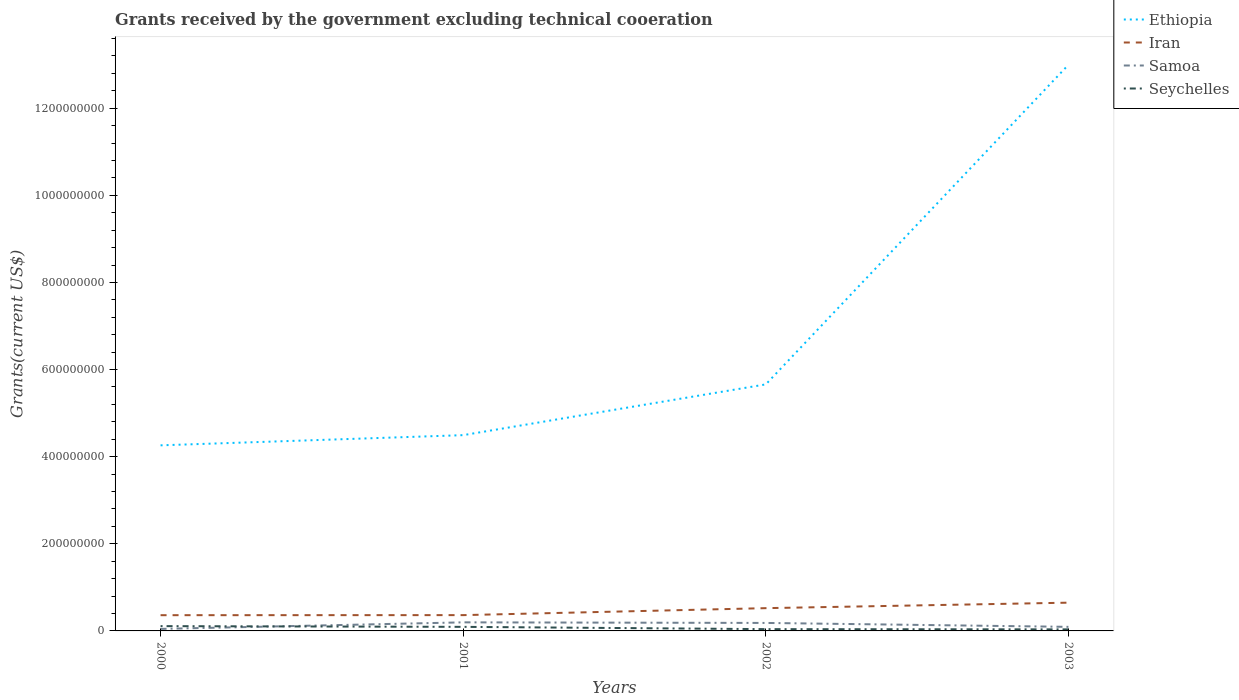How many different coloured lines are there?
Keep it short and to the point. 4. Is the number of lines equal to the number of legend labels?
Offer a very short reply. Yes. Across all years, what is the maximum total grants received by the government in Seychelles?
Provide a succinct answer. 3.54e+06. In which year was the total grants received by the government in Ethiopia maximum?
Provide a succinct answer. 2000. What is the total total grants received by the government in Seychelles in the graph?
Provide a short and direct response. 5.60e+05. What is the difference between the highest and the second highest total grants received by the government in Samoa?
Provide a succinct answer. 1.51e+07. What is the difference between the highest and the lowest total grants received by the government in Samoa?
Ensure brevity in your answer.  2. Is the total grants received by the government in Iran strictly greater than the total grants received by the government in Ethiopia over the years?
Your answer should be compact. Yes. What is the difference between two consecutive major ticks on the Y-axis?
Your answer should be very brief. 2.00e+08. Are the values on the major ticks of Y-axis written in scientific E-notation?
Ensure brevity in your answer.  No. Does the graph contain any zero values?
Ensure brevity in your answer.  No. How many legend labels are there?
Your answer should be compact. 4. How are the legend labels stacked?
Keep it short and to the point. Vertical. What is the title of the graph?
Offer a terse response. Grants received by the government excluding technical cooeration. Does "Malaysia" appear as one of the legend labels in the graph?
Offer a terse response. No. What is the label or title of the X-axis?
Make the answer very short. Years. What is the label or title of the Y-axis?
Your answer should be very brief. Grants(current US$). What is the Grants(current US$) of Ethiopia in 2000?
Offer a very short reply. 4.26e+08. What is the Grants(current US$) in Iran in 2000?
Your answer should be compact. 3.61e+07. What is the Grants(current US$) of Samoa in 2000?
Offer a terse response. 4.62e+06. What is the Grants(current US$) in Seychelles in 2000?
Provide a succinct answer. 1.10e+07. What is the Grants(current US$) of Ethiopia in 2001?
Offer a very short reply. 4.49e+08. What is the Grants(current US$) in Iran in 2001?
Offer a very short reply. 3.63e+07. What is the Grants(current US$) in Samoa in 2001?
Your answer should be compact. 1.97e+07. What is the Grants(current US$) of Seychelles in 2001?
Keep it short and to the point. 9.35e+06. What is the Grants(current US$) of Ethiopia in 2002?
Keep it short and to the point. 5.66e+08. What is the Grants(current US$) in Iran in 2002?
Keep it short and to the point. 5.23e+07. What is the Grants(current US$) in Samoa in 2002?
Your response must be concise. 1.83e+07. What is the Grants(current US$) in Seychelles in 2002?
Provide a succinct answer. 4.10e+06. What is the Grants(current US$) in Ethiopia in 2003?
Give a very brief answer. 1.30e+09. What is the Grants(current US$) of Iran in 2003?
Ensure brevity in your answer.  6.48e+07. What is the Grants(current US$) in Samoa in 2003?
Ensure brevity in your answer.  9.34e+06. What is the Grants(current US$) of Seychelles in 2003?
Your answer should be compact. 3.54e+06. Across all years, what is the maximum Grants(current US$) of Ethiopia?
Make the answer very short. 1.30e+09. Across all years, what is the maximum Grants(current US$) in Iran?
Offer a terse response. 6.48e+07. Across all years, what is the maximum Grants(current US$) in Samoa?
Offer a terse response. 1.97e+07. Across all years, what is the maximum Grants(current US$) of Seychelles?
Your response must be concise. 1.10e+07. Across all years, what is the minimum Grants(current US$) of Ethiopia?
Keep it short and to the point. 4.26e+08. Across all years, what is the minimum Grants(current US$) in Iran?
Your answer should be compact. 3.61e+07. Across all years, what is the minimum Grants(current US$) in Samoa?
Offer a terse response. 4.62e+06. Across all years, what is the minimum Grants(current US$) of Seychelles?
Keep it short and to the point. 3.54e+06. What is the total Grants(current US$) in Ethiopia in the graph?
Offer a terse response. 2.74e+09. What is the total Grants(current US$) of Iran in the graph?
Provide a succinct answer. 1.90e+08. What is the total Grants(current US$) of Samoa in the graph?
Keep it short and to the point. 5.20e+07. What is the total Grants(current US$) of Seychelles in the graph?
Your answer should be compact. 2.80e+07. What is the difference between the Grants(current US$) in Ethiopia in 2000 and that in 2001?
Provide a short and direct response. -2.34e+07. What is the difference between the Grants(current US$) of Samoa in 2000 and that in 2001?
Your answer should be compact. -1.51e+07. What is the difference between the Grants(current US$) of Seychelles in 2000 and that in 2001?
Offer a very short reply. 1.66e+06. What is the difference between the Grants(current US$) of Ethiopia in 2000 and that in 2002?
Keep it short and to the point. -1.40e+08. What is the difference between the Grants(current US$) in Iran in 2000 and that in 2002?
Keep it short and to the point. -1.61e+07. What is the difference between the Grants(current US$) of Samoa in 2000 and that in 2002?
Provide a short and direct response. -1.37e+07. What is the difference between the Grants(current US$) in Seychelles in 2000 and that in 2002?
Make the answer very short. 6.91e+06. What is the difference between the Grants(current US$) in Ethiopia in 2000 and that in 2003?
Provide a succinct answer. -8.74e+08. What is the difference between the Grants(current US$) of Iran in 2000 and that in 2003?
Your answer should be very brief. -2.87e+07. What is the difference between the Grants(current US$) of Samoa in 2000 and that in 2003?
Offer a very short reply. -4.72e+06. What is the difference between the Grants(current US$) of Seychelles in 2000 and that in 2003?
Offer a very short reply. 7.47e+06. What is the difference between the Grants(current US$) of Ethiopia in 2001 and that in 2002?
Your answer should be very brief. -1.17e+08. What is the difference between the Grants(current US$) of Iran in 2001 and that in 2002?
Provide a succinct answer. -1.60e+07. What is the difference between the Grants(current US$) in Samoa in 2001 and that in 2002?
Offer a terse response. 1.34e+06. What is the difference between the Grants(current US$) of Seychelles in 2001 and that in 2002?
Ensure brevity in your answer.  5.25e+06. What is the difference between the Grants(current US$) of Ethiopia in 2001 and that in 2003?
Your answer should be very brief. -8.50e+08. What is the difference between the Grants(current US$) in Iran in 2001 and that in 2003?
Keep it short and to the point. -2.86e+07. What is the difference between the Grants(current US$) in Samoa in 2001 and that in 2003?
Your answer should be compact. 1.03e+07. What is the difference between the Grants(current US$) in Seychelles in 2001 and that in 2003?
Ensure brevity in your answer.  5.81e+06. What is the difference between the Grants(current US$) in Ethiopia in 2002 and that in 2003?
Provide a short and direct response. -7.34e+08. What is the difference between the Grants(current US$) of Iran in 2002 and that in 2003?
Ensure brevity in your answer.  -1.26e+07. What is the difference between the Grants(current US$) of Samoa in 2002 and that in 2003?
Offer a very short reply. 9.00e+06. What is the difference between the Grants(current US$) in Seychelles in 2002 and that in 2003?
Your answer should be compact. 5.60e+05. What is the difference between the Grants(current US$) in Ethiopia in 2000 and the Grants(current US$) in Iran in 2001?
Ensure brevity in your answer.  3.90e+08. What is the difference between the Grants(current US$) in Ethiopia in 2000 and the Grants(current US$) in Samoa in 2001?
Give a very brief answer. 4.06e+08. What is the difference between the Grants(current US$) in Ethiopia in 2000 and the Grants(current US$) in Seychelles in 2001?
Give a very brief answer. 4.17e+08. What is the difference between the Grants(current US$) of Iran in 2000 and the Grants(current US$) of Samoa in 2001?
Your response must be concise. 1.64e+07. What is the difference between the Grants(current US$) in Iran in 2000 and the Grants(current US$) in Seychelles in 2001?
Keep it short and to the point. 2.68e+07. What is the difference between the Grants(current US$) of Samoa in 2000 and the Grants(current US$) of Seychelles in 2001?
Give a very brief answer. -4.73e+06. What is the difference between the Grants(current US$) of Ethiopia in 2000 and the Grants(current US$) of Iran in 2002?
Offer a terse response. 3.74e+08. What is the difference between the Grants(current US$) in Ethiopia in 2000 and the Grants(current US$) in Samoa in 2002?
Provide a short and direct response. 4.08e+08. What is the difference between the Grants(current US$) in Ethiopia in 2000 and the Grants(current US$) in Seychelles in 2002?
Give a very brief answer. 4.22e+08. What is the difference between the Grants(current US$) of Iran in 2000 and the Grants(current US$) of Samoa in 2002?
Give a very brief answer. 1.78e+07. What is the difference between the Grants(current US$) in Iran in 2000 and the Grants(current US$) in Seychelles in 2002?
Your answer should be very brief. 3.20e+07. What is the difference between the Grants(current US$) of Samoa in 2000 and the Grants(current US$) of Seychelles in 2002?
Ensure brevity in your answer.  5.20e+05. What is the difference between the Grants(current US$) of Ethiopia in 2000 and the Grants(current US$) of Iran in 2003?
Make the answer very short. 3.61e+08. What is the difference between the Grants(current US$) in Ethiopia in 2000 and the Grants(current US$) in Samoa in 2003?
Your answer should be compact. 4.17e+08. What is the difference between the Grants(current US$) in Ethiopia in 2000 and the Grants(current US$) in Seychelles in 2003?
Give a very brief answer. 4.23e+08. What is the difference between the Grants(current US$) in Iran in 2000 and the Grants(current US$) in Samoa in 2003?
Offer a terse response. 2.68e+07. What is the difference between the Grants(current US$) of Iran in 2000 and the Grants(current US$) of Seychelles in 2003?
Offer a terse response. 3.26e+07. What is the difference between the Grants(current US$) in Samoa in 2000 and the Grants(current US$) in Seychelles in 2003?
Keep it short and to the point. 1.08e+06. What is the difference between the Grants(current US$) of Ethiopia in 2001 and the Grants(current US$) of Iran in 2002?
Offer a terse response. 3.97e+08. What is the difference between the Grants(current US$) of Ethiopia in 2001 and the Grants(current US$) of Samoa in 2002?
Keep it short and to the point. 4.31e+08. What is the difference between the Grants(current US$) in Ethiopia in 2001 and the Grants(current US$) in Seychelles in 2002?
Offer a very short reply. 4.45e+08. What is the difference between the Grants(current US$) of Iran in 2001 and the Grants(current US$) of Samoa in 2002?
Ensure brevity in your answer.  1.79e+07. What is the difference between the Grants(current US$) in Iran in 2001 and the Grants(current US$) in Seychelles in 2002?
Offer a very short reply. 3.22e+07. What is the difference between the Grants(current US$) in Samoa in 2001 and the Grants(current US$) in Seychelles in 2002?
Your response must be concise. 1.56e+07. What is the difference between the Grants(current US$) in Ethiopia in 2001 and the Grants(current US$) in Iran in 2003?
Provide a short and direct response. 3.85e+08. What is the difference between the Grants(current US$) in Ethiopia in 2001 and the Grants(current US$) in Samoa in 2003?
Offer a terse response. 4.40e+08. What is the difference between the Grants(current US$) in Ethiopia in 2001 and the Grants(current US$) in Seychelles in 2003?
Make the answer very short. 4.46e+08. What is the difference between the Grants(current US$) of Iran in 2001 and the Grants(current US$) of Samoa in 2003?
Your answer should be very brief. 2.69e+07. What is the difference between the Grants(current US$) in Iran in 2001 and the Grants(current US$) in Seychelles in 2003?
Ensure brevity in your answer.  3.27e+07. What is the difference between the Grants(current US$) of Samoa in 2001 and the Grants(current US$) of Seychelles in 2003?
Provide a succinct answer. 1.61e+07. What is the difference between the Grants(current US$) of Ethiopia in 2002 and the Grants(current US$) of Iran in 2003?
Give a very brief answer. 5.01e+08. What is the difference between the Grants(current US$) in Ethiopia in 2002 and the Grants(current US$) in Samoa in 2003?
Make the answer very short. 5.57e+08. What is the difference between the Grants(current US$) in Ethiopia in 2002 and the Grants(current US$) in Seychelles in 2003?
Your response must be concise. 5.62e+08. What is the difference between the Grants(current US$) in Iran in 2002 and the Grants(current US$) in Samoa in 2003?
Offer a terse response. 4.29e+07. What is the difference between the Grants(current US$) in Iran in 2002 and the Grants(current US$) in Seychelles in 2003?
Provide a short and direct response. 4.87e+07. What is the difference between the Grants(current US$) of Samoa in 2002 and the Grants(current US$) of Seychelles in 2003?
Your response must be concise. 1.48e+07. What is the average Grants(current US$) in Ethiopia per year?
Your answer should be compact. 6.85e+08. What is the average Grants(current US$) of Iran per year?
Keep it short and to the point. 4.74e+07. What is the average Grants(current US$) in Samoa per year?
Give a very brief answer. 1.30e+07. What is the average Grants(current US$) of Seychelles per year?
Give a very brief answer. 7.00e+06. In the year 2000, what is the difference between the Grants(current US$) in Ethiopia and Grants(current US$) in Iran?
Offer a very short reply. 3.90e+08. In the year 2000, what is the difference between the Grants(current US$) in Ethiopia and Grants(current US$) in Samoa?
Ensure brevity in your answer.  4.21e+08. In the year 2000, what is the difference between the Grants(current US$) in Ethiopia and Grants(current US$) in Seychelles?
Ensure brevity in your answer.  4.15e+08. In the year 2000, what is the difference between the Grants(current US$) of Iran and Grants(current US$) of Samoa?
Make the answer very short. 3.15e+07. In the year 2000, what is the difference between the Grants(current US$) of Iran and Grants(current US$) of Seychelles?
Provide a short and direct response. 2.51e+07. In the year 2000, what is the difference between the Grants(current US$) of Samoa and Grants(current US$) of Seychelles?
Provide a short and direct response. -6.39e+06. In the year 2001, what is the difference between the Grants(current US$) in Ethiopia and Grants(current US$) in Iran?
Provide a succinct answer. 4.13e+08. In the year 2001, what is the difference between the Grants(current US$) of Ethiopia and Grants(current US$) of Samoa?
Give a very brief answer. 4.30e+08. In the year 2001, what is the difference between the Grants(current US$) of Ethiopia and Grants(current US$) of Seychelles?
Give a very brief answer. 4.40e+08. In the year 2001, what is the difference between the Grants(current US$) in Iran and Grants(current US$) in Samoa?
Give a very brief answer. 1.66e+07. In the year 2001, what is the difference between the Grants(current US$) of Iran and Grants(current US$) of Seychelles?
Your answer should be very brief. 2.69e+07. In the year 2001, what is the difference between the Grants(current US$) in Samoa and Grants(current US$) in Seychelles?
Provide a short and direct response. 1.03e+07. In the year 2002, what is the difference between the Grants(current US$) in Ethiopia and Grants(current US$) in Iran?
Provide a short and direct response. 5.14e+08. In the year 2002, what is the difference between the Grants(current US$) of Ethiopia and Grants(current US$) of Samoa?
Offer a terse response. 5.48e+08. In the year 2002, what is the difference between the Grants(current US$) of Ethiopia and Grants(current US$) of Seychelles?
Offer a terse response. 5.62e+08. In the year 2002, what is the difference between the Grants(current US$) of Iran and Grants(current US$) of Samoa?
Keep it short and to the point. 3.39e+07. In the year 2002, what is the difference between the Grants(current US$) of Iran and Grants(current US$) of Seychelles?
Your answer should be compact. 4.82e+07. In the year 2002, what is the difference between the Grants(current US$) of Samoa and Grants(current US$) of Seychelles?
Your answer should be very brief. 1.42e+07. In the year 2003, what is the difference between the Grants(current US$) in Ethiopia and Grants(current US$) in Iran?
Offer a terse response. 1.23e+09. In the year 2003, what is the difference between the Grants(current US$) of Ethiopia and Grants(current US$) of Samoa?
Provide a short and direct response. 1.29e+09. In the year 2003, what is the difference between the Grants(current US$) in Ethiopia and Grants(current US$) in Seychelles?
Keep it short and to the point. 1.30e+09. In the year 2003, what is the difference between the Grants(current US$) in Iran and Grants(current US$) in Samoa?
Offer a very short reply. 5.55e+07. In the year 2003, what is the difference between the Grants(current US$) of Iran and Grants(current US$) of Seychelles?
Make the answer very short. 6.13e+07. In the year 2003, what is the difference between the Grants(current US$) of Samoa and Grants(current US$) of Seychelles?
Your response must be concise. 5.80e+06. What is the ratio of the Grants(current US$) in Ethiopia in 2000 to that in 2001?
Offer a terse response. 0.95. What is the ratio of the Grants(current US$) of Samoa in 2000 to that in 2001?
Offer a very short reply. 0.23. What is the ratio of the Grants(current US$) in Seychelles in 2000 to that in 2001?
Offer a terse response. 1.18. What is the ratio of the Grants(current US$) in Ethiopia in 2000 to that in 2002?
Ensure brevity in your answer.  0.75. What is the ratio of the Grants(current US$) of Iran in 2000 to that in 2002?
Offer a very short reply. 0.69. What is the ratio of the Grants(current US$) in Samoa in 2000 to that in 2002?
Keep it short and to the point. 0.25. What is the ratio of the Grants(current US$) in Seychelles in 2000 to that in 2002?
Your answer should be very brief. 2.69. What is the ratio of the Grants(current US$) of Ethiopia in 2000 to that in 2003?
Provide a short and direct response. 0.33. What is the ratio of the Grants(current US$) in Iran in 2000 to that in 2003?
Ensure brevity in your answer.  0.56. What is the ratio of the Grants(current US$) of Samoa in 2000 to that in 2003?
Your answer should be very brief. 0.49. What is the ratio of the Grants(current US$) in Seychelles in 2000 to that in 2003?
Your answer should be compact. 3.11. What is the ratio of the Grants(current US$) of Ethiopia in 2001 to that in 2002?
Make the answer very short. 0.79. What is the ratio of the Grants(current US$) in Iran in 2001 to that in 2002?
Keep it short and to the point. 0.69. What is the ratio of the Grants(current US$) of Samoa in 2001 to that in 2002?
Your response must be concise. 1.07. What is the ratio of the Grants(current US$) in Seychelles in 2001 to that in 2002?
Offer a very short reply. 2.28. What is the ratio of the Grants(current US$) in Ethiopia in 2001 to that in 2003?
Ensure brevity in your answer.  0.35. What is the ratio of the Grants(current US$) in Iran in 2001 to that in 2003?
Ensure brevity in your answer.  0.56. What is the ratio of the Grants(current US$) of Samoa in 2001 to that in 2003?
Provide a short and direct response. 2.11. What is the ratio of the Grants(current US$) of Seychelles in 2001 to that in 2003?
Offer a very short reply. 2.64. What is the ratio of the Grants(current US$) in Ethiopia in 2002 to that in 2003?
Keep it short and to the point. 0.44. What is the ratio of the Grants(current US$) in Iran in 2002 to that in 2003?
Keep it short and to the point. 0.81. What is the ratio of the Grants(current US$) in Samoa in 2002 to that in 2003?
Provide a succinct answer. 1.96. What is the ratio of the Grants(current US$) of Seychelles in 2002 to that in 2003?
Your answer should be compact. 1.16. What is the difference between the highest and the second highest Grants(current US$) in Ethiopia?
Provide a succinct answer. 7.34e+08. What is the difference between the highest and the second highest Grants(current US$) in Iran?
Your answer should be compact. 1.26e+07. What is the difference between the highest and the second highest Grants(current US$) of Samoa?
Your answer should be very brief. 1.34e+06. What is the difference between the highest and the second highest Grants(current US$) in Seychelles?
Provide a succinct answer. 1.66e+06. What is the difference between the highest and the lowest Grants(current US$) in Ethiopia?
Offer a very short reply. 8.74e+08. What is the difference between the highest and the lowest Grants(current US$) of Iran?
Give a very brief answer. 2.87e+07. What is the difference between the highest and the lowest Grants(current US$) in Samoa?
Your response must be concise. 1.51e+07. What is the difference between the highest and the lowest Grants(current US$) in Seychelles?
Provide a succinct answer. 7.47e+06. 